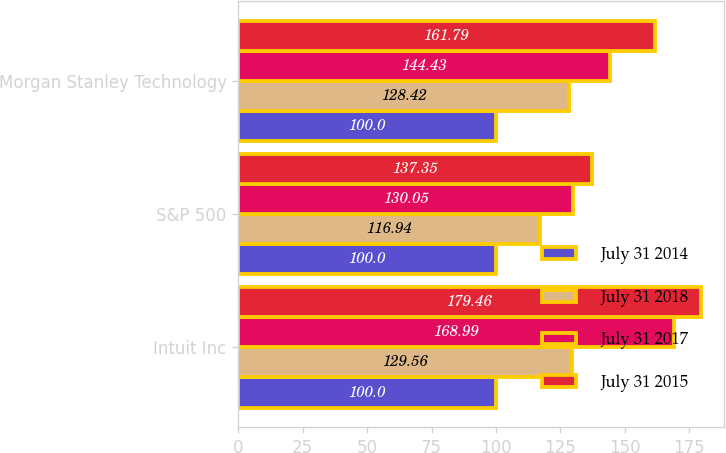<chart> <loc_0><loc_0><loc_500><loc_500><stacked_bar_chart><ecel><fcel>Intuit Inc<fcel>S&P 500<fcel>Morgan Stanley Technology<nl><fcel>July 31 2014<fcel>100<fcel>100<fcel>100<nl><fcel>July 31 2018<fcel>129.56<fcel>116.94<fcel>128.42<nl><fcel>July 31 2017<fcel>168.99<fcel>130.05<fcel>144.43<nl><fcel>July 31 2015<fcel>179.46<fcel>137.35<fcel>161.79<nl></chart> 